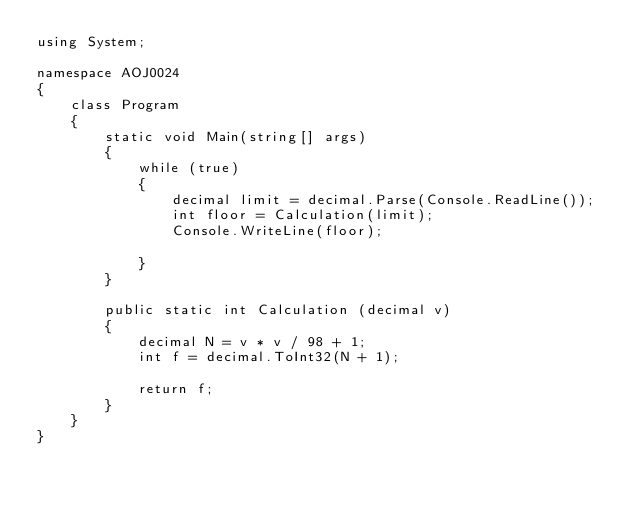Convert code to text. <code><loc_0><loc_0><loc_500><loc_500><_C#_>using System;

namespace AOJ0024
{
    class Program
    {
        static void Main(string[] args)
        {
            while (true)
            {
                decimal limit = decimal.Parse(Console.ReadLine());
                int floor = Calculation(limit);
                Console.WriteLine(floor);

            }
        }

        public static int Calculation (decimal v)
        {
            decimal N = v * v / 98 + 1;
            int f = decimal.ToInt32(N + 1);

            return f;
        }
    }
}</code> 